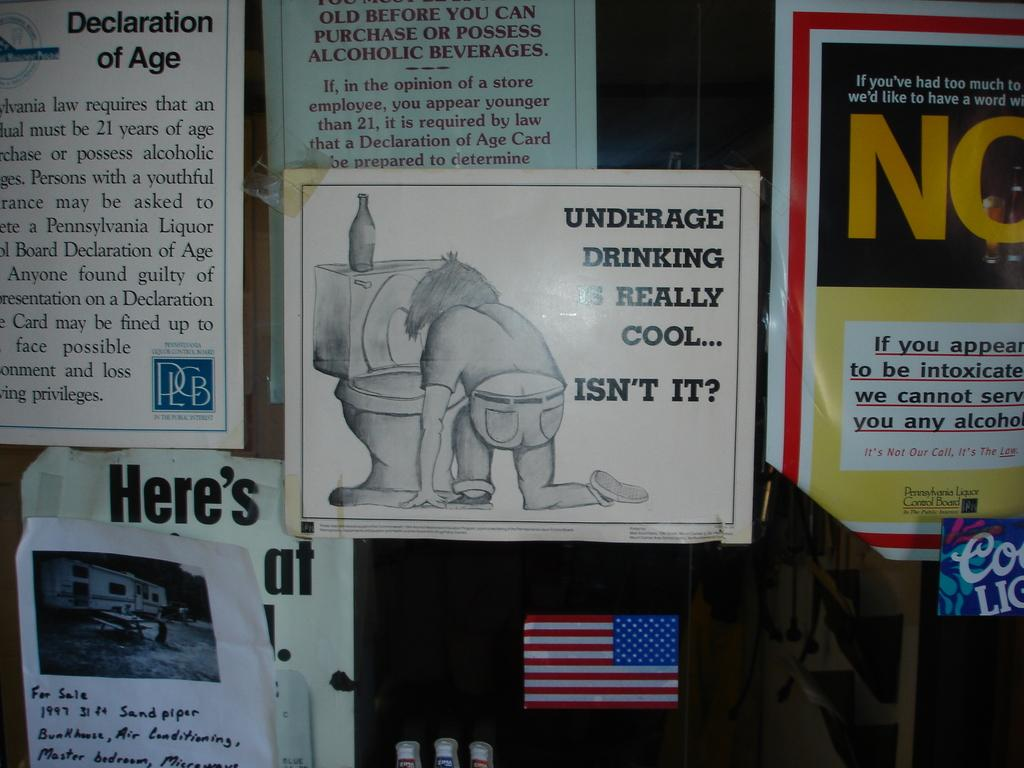<image>
Write a terse but informative summary of the picture. A bulletin board showing a flyer against underage drinking. 